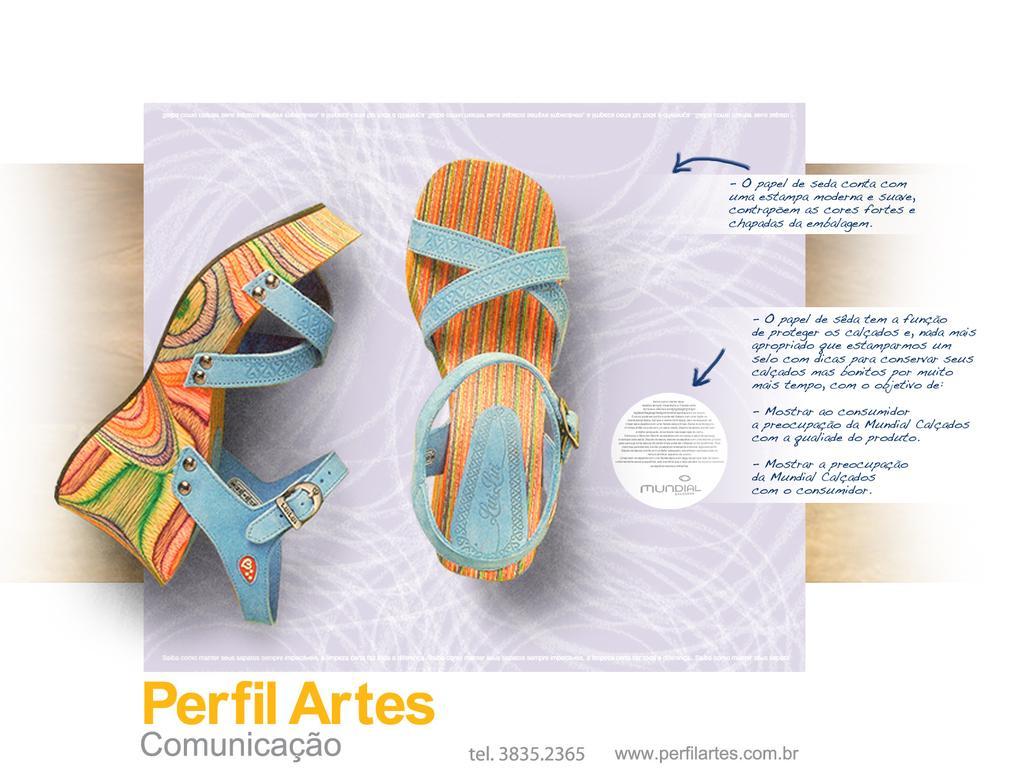Can you describe this image briefly? This image consists of footwear. There is something written at the bottom and right side. This looks like an advertisement. 